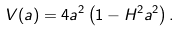<formula> <loc_0><loc_0><loc_500><loc_500>V ( a ) = 4 a ^ { 2 } \left ( 1 - H ^ { 2 } a ^ { 2 } \right ) .</formula> 